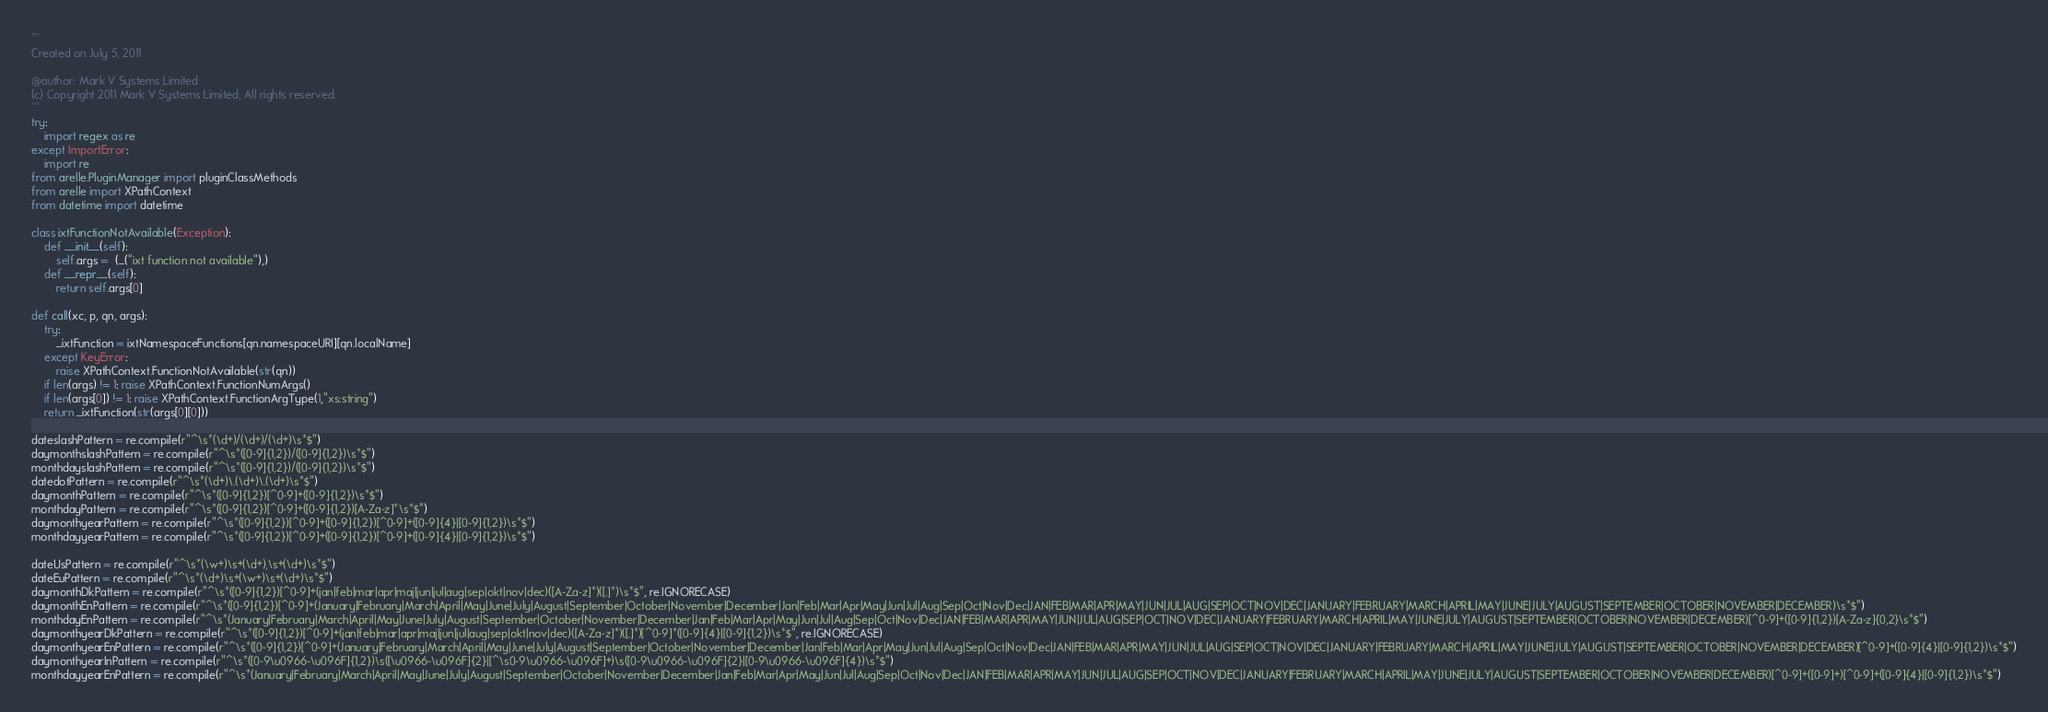<code> <loc_0><loc_0><loc_500><loc_500><_Python_>'''
Created on July 5, 2011

@author: Mark V Systems Limited
(c) Copyright 2011 Mark V Systems Limited, All rights reserved.
'''
try:
    import regex as re
except ImportError:
    import re
from arelle.PluginManager import pluginClassMethods
from arelle import XPathContext
from datetime import datetime

class ixtFunctionNotAvailable(Exception):
    def __init__(self):
        self.args =  (_("ixt function not available"),)
    def __repr__(self):
        return self.args[0]
    
def call(xc, p, qn, args):
    try:
        _ixtFunction = ixtNamespaceFunctions[qn.namespaceURI][qn.localName]
    except KeyError:
        raise XPathContext.FunctionNotAvailable(str(qn))
    if len(args) != 1: raise XPathContext.FunctionNumArgs()
    if len(args[0]) != 1: raise XPathContext.FunctionArgType(1,"xs:string")
    return _ixtFunction(str(args[0][0]))

dateslashPattern = re.compile(r"^\s*(\d+)/(\d+)/(\d+)\s*$")
daymonthslashPattern = re.compile(r"^\s*([0-9]{1,2})/([0-9]{1,2})\s*$")
monthdayslashPattern = re.compile(r"^\s*([0-9]{1,2})/([0-9]{1,2})\s*$")
datedotPattern = re.compile(r"^\s*(\d+)\.(\d+)\.(\d+)\s*$")
daymonthPattern = re.compile(r"^\s*([0-9]{1,2})[^0-9]+([0-9]{1,2})\s*$")
monthdayPattern = re.compile(r"^\s*([0-9]{1,2})[^0-9]+([0-9]{1,2})[A-Za-z]*\s*$")
daymonthyearPattern = re.compile(r"^\s*([0-9]{1,2})[^0-9]+([0-9]{1,2})[^0-9]+([0-9]{4}|[0-9]{1,2})\s*$")
monthdayyearPattern = re.compile(r"^\s*([0-9]{1,2})[^0-9]+([0-9]{1,2})[^0-9]+([0-9]{4}|[0-9]{1,2})\s*$")

dateUsPattern = re.compile(r"^\s*(\w+)\s+(\d+),\s+(\d+)\s*$")
dateEuPattern = re.compile(r"^\s*(\d+)\s+(\w+)\s+(\d+)\s*$")
daymonthDkPattern = re.compile(r"^\s*([0-9]{1,2})[^0-9]+(jan|feb|mar|apr|maj|jun|jul|aug|sep|okt|nov|dec)([A-Za-z]*)([.]*)\s*$", re.IGNORECASE)
daymonthEnPattern = re.compile(r"^\s*([0-9]{1,2})[^0-9]+(January|February|March|April|May|June|July|August|September|October|November|December|Jan|Feb|Mar|Apr|May|Jun|Jul|Aug|Sep|Oct|Nov|Dec|JAN|FEB|MAR|APR|MAY|JUN|JUL|AUG|SEP|OCT|NOV|DEC|JANUARY|FEBRUARY|MARCH|APRIL|MAY|JUNE|JULY|AUGUST|SEPTEMBER|OCTOBER|NOVEMBER|DECEMBER)\s*$")
monthdayEnPattern = re.compile(r"^\s*(January|February|March|April|May|June|July|August|September|October|November|December|Jan|Feb|Mar|Apr|May|Jun|Jul|Aug|Sep|Oct|Nov|Dec|JAN|FEB|MAR|APR|MAY|JUN|JUL|AUG|SEP|OCT|NOV|DEC|JANUARY|FEBRUARY|MARCH|APRIL|MAY|JUNE|JULY|AUGUST|SEPTEMBER|OCTOBER|NOVEMBER|DECEMBER)[^0-9]+([0-9]{1,2})[A-Za-z]{0,2}\s*$")
daymonthyearDkPattern = re.compile(r"^\s*([0-9]{1,2})[^0-9]+(jan|feb|mar|apr|maj|jun|jul|aug|sep|okt|nov|dec)([A-Za-z]*)([.]*)[^0-9]*([0-9]{4}|[0-9]{1,2})\s*$", re.IGNORECASE)
daymonthyearEnPattern = re.compile(r"^\s*([0-9]{1,2})[^0-9]+(January|February|March|April|May|June|July|August|September|October|November|December|Jan|Feb|Mar|Apr|May|Jun|Jul|Aug|Sep|Oct|Nov|Dec|JAN|FEB|MAR|APR|MAY|JUN|JUL|AUG|SEP|OCT|NOV|DEC|JANUARY|FEBRUARY|MARCH|APRIL|MAY|JUNE|JULY|AUGUST|SEPTEMBER|OCTOBER|NOVEMBER|DECEMBER)[^0-9]+([0-9]{4}|[0-9]{1,2})\s*$")
daymonthyearInPattern = re.compile(r"^\s*([0-9\u0966-\u096F]{1,2})\s([\u0966-\u096F]{2}|[^\s0-9\u0966-\u096F]+)\s([0-9\u0966-\u096F]{2}|[0-9\u0966-\u096F]{4})\s*$")
monthdayyearEnPattern = re.compile(r"^\s*(January|February|March|April|May|June|July|August|September|October|November|December|Jan|Feb|Mar|Apr|May|Jun|Jul|Aug|Sep|Oct|Nov|Dec|JAN|FEB|MAR|APR|MAY|JUN|JUL|AUG|SEP|OCT|NOV|DEC|JANUARY|FEBRUARY|MARCH|APRIL|MAY|JUNE|JULY|AUGUST|SEPTEMBER|OCTOBER|NOVEMBER|DECEMBER)[^0-9]+([0-9]+)[^0-9]+([0-9]{4}|[0-9]{1,2})\s*$")</code> 